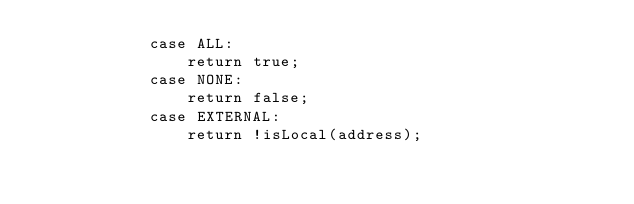Convert code to text. <code><loc_0><loc_0><loc_500><loc_500><_Java_>            case ALL:
                return true;
            case NONE:
                return false;
            case EXTERNAL:
                return !isLocal(address);</code> 